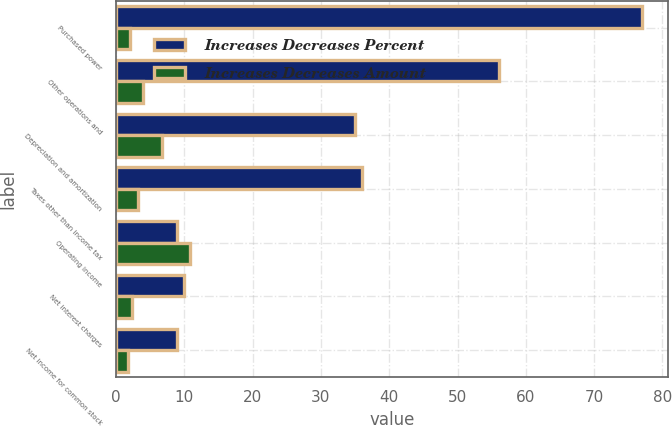<chart> <loc_0><loc_0><loc_500><loc_500><stacked_bar_chart><ecel><fcel>Purchased power<fcel>Other operations and<fcel>Depreciation and amortization<fcel>Taxes other than income tax<fcel>Operating income<fcel>Net interest charges<fcel>Net income for common stock<nl><fcel>Increases Decreases Percent<fcel>77<fcel>56<fcel>35<fcel>36<fcel>9<fcel>10<fcel>9<nl><fcel>Increases Decreases Amount<fcel>2<fcel>3.9<fcel>6.8<fcel>3.2<fcel>10.8<fcel>2.3<fcel>1.7<nl></chart> 